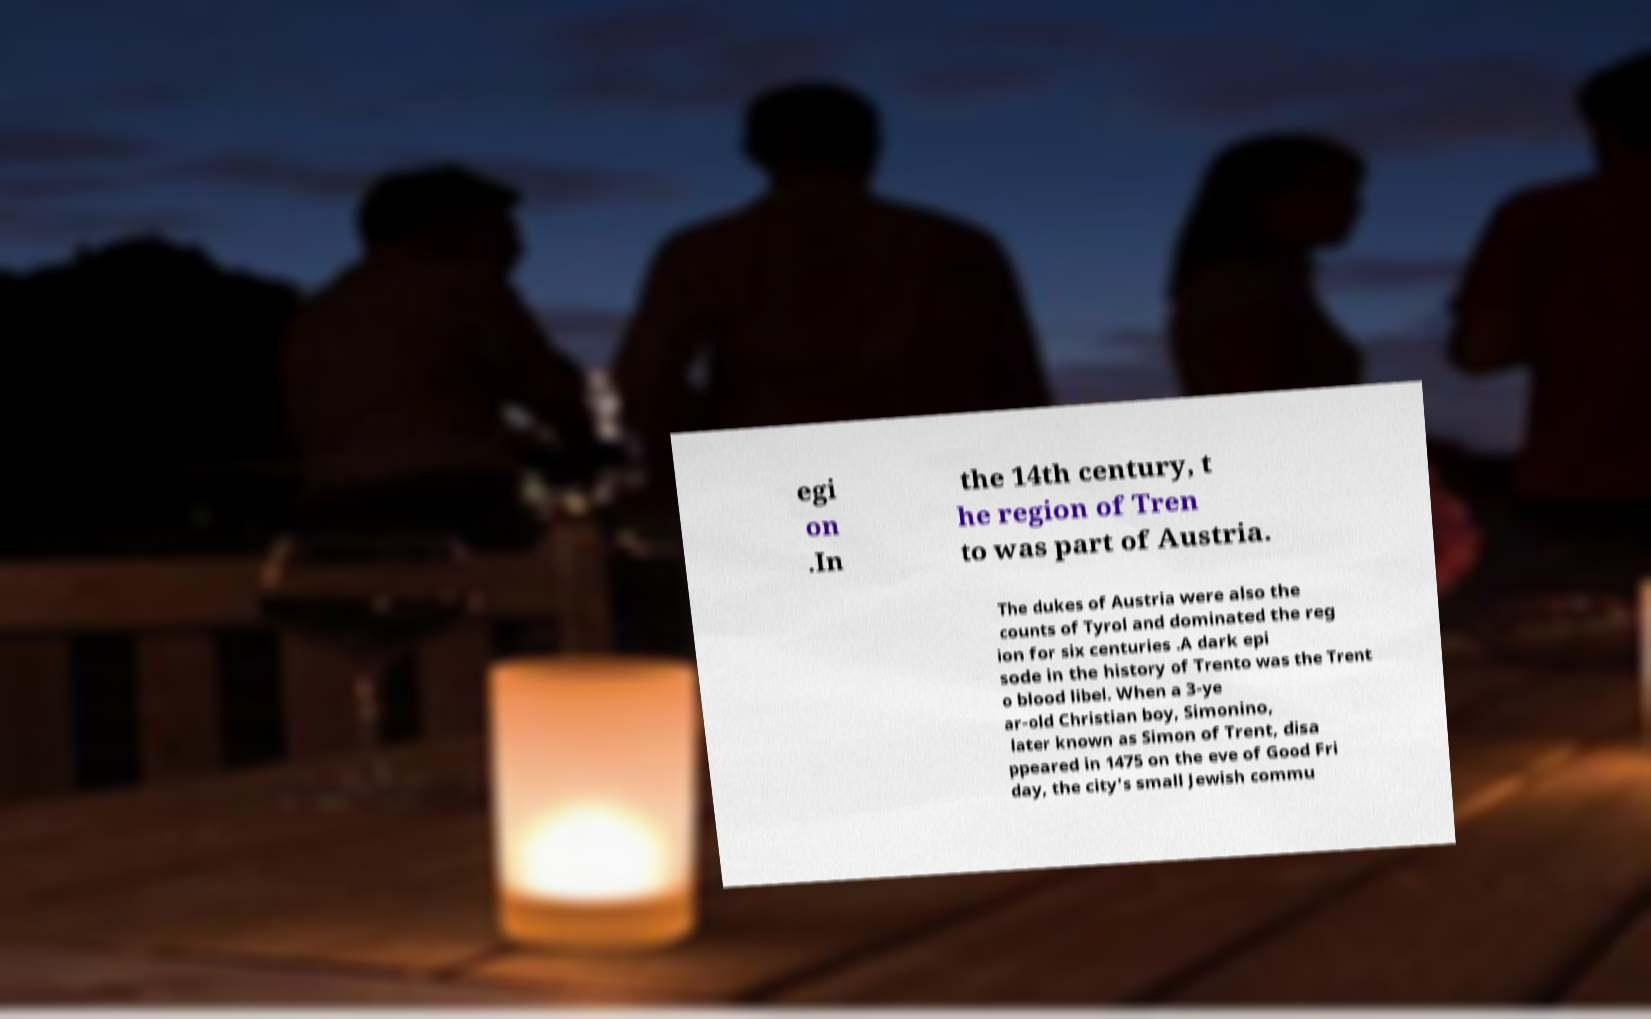Could you assist in decoding the text presented in this image and type it out clearly? egi on .In the 14th century, t he region of Tren to was part of Austria. The dukes of Austria were also the counts of Tyrol and dominated the reg ion for six centuries .A dark epi sode in the history of Trento was the Trent o blood libel. When a 3-ye ar-old Christian boy, Simonino, later known as Simon of Trent, disa ppeared in 1475 on the eve of Good Fri day, the city's small Jewish commu 